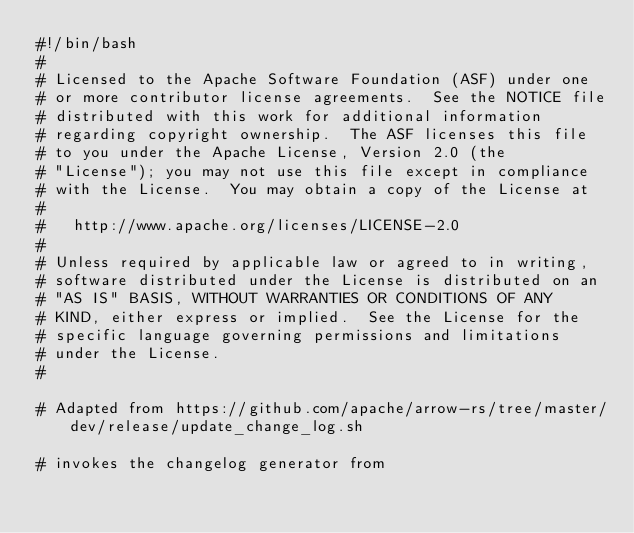<code> <loc_0><loc_0><loc_500><loc_500><_Bash_>#!/bin/bash
#
# Licensed to the Apache Software Foundation (ASF) under one
# or more contributor license agreements.  See the NOTICE file
# distributed with this work for additional information
# regarding copyright ownership.  The ASF licenses this file
# to you under the Apache License, Version 2.0 (the
# "License"); you may not use this file except in compliance
# with the License.  You may obtain a copy of the License at
#
#   http://www.apache.org/licenses/LICENSE-2.0
#
# Unless required by applicable law or agreed to in writing,
# software distributed under the License is distributed on an
# "AS IS" BASIS, WITHOUT WARRANTIES OR CONDITIONS OF ANY
# KIND, either express or implied.  See the License for the
# specific language governing permissions and limitations
# under the License.
#

# Adapted from https://github.com/apache/arrow-rs/tree/master/dev/release/update_change_log.sh

# invokes the changelog generator from</code> 